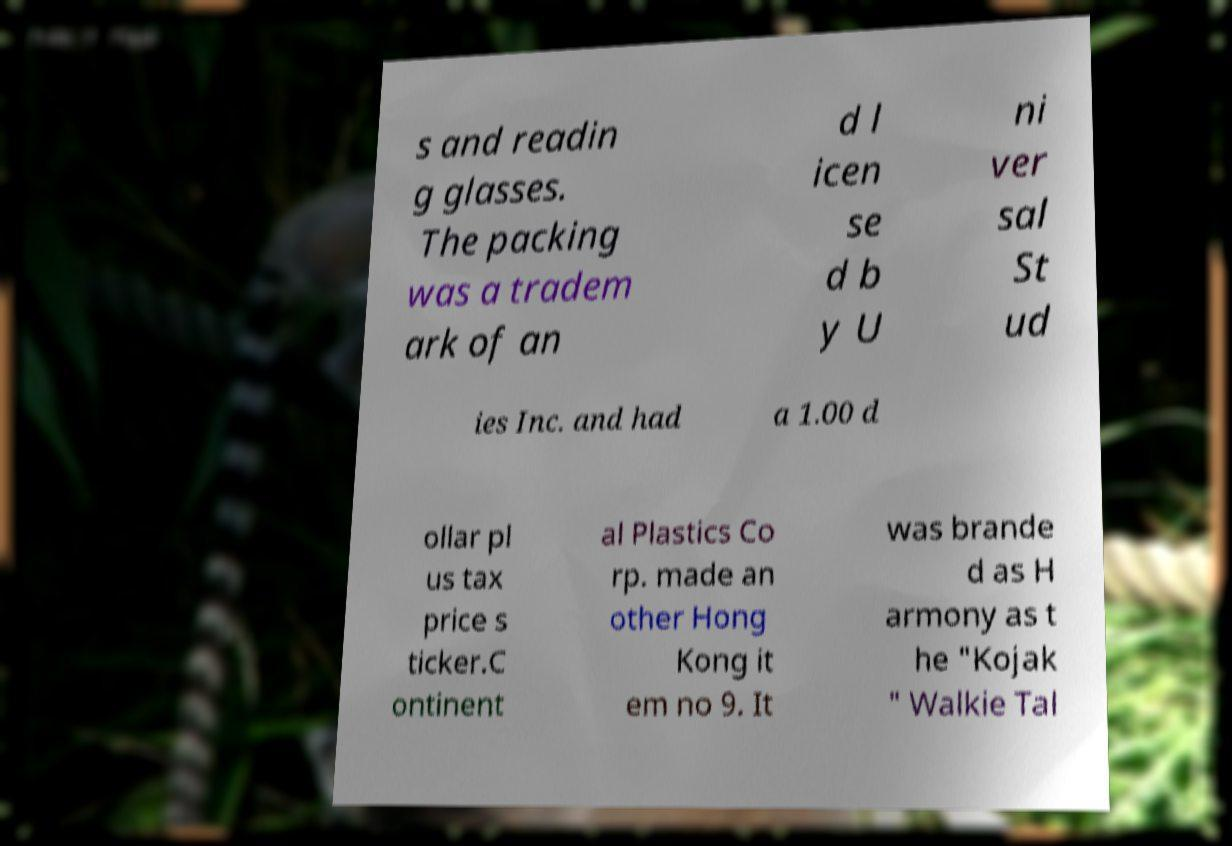Please identify and transcribe the text found in this image. s and readin g glasses. The packing was a tradem ark of an d l icen se d b y U ni ver sal St ud ies Inc. and had a 1.00 d ollar pl us tax price s ticker.C ontinent al Plastics Co rp. made an other Hong Kong it em no 9. It was brande d as H armony as t he "Kojak " Walkie Tal 